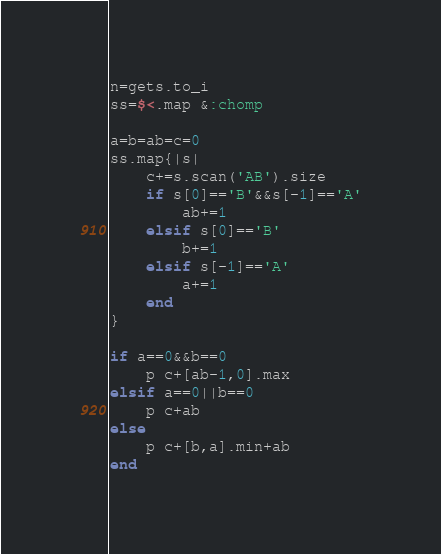<code> <loc_0><loc_0><loc_500><loc_500><_Ruby_>n=gets.to_i
ss=$<.map &:chomp

a=b=ab=c=0
ss.map{|s|
	c+=s.scan('AB').size
	if s[0]=='B'&&s[-1]=='A'
		ab+=1
	elsif s[0]=='B'
		b+=1
	elsif s[-1]=='A'
		a+=1
	end
}

if a==0&&b==0
	p c+[ab-1,0].max
elsif a==0||b==0
	p c+ab
else
	p c+[b,a].min+ab
end</code> 